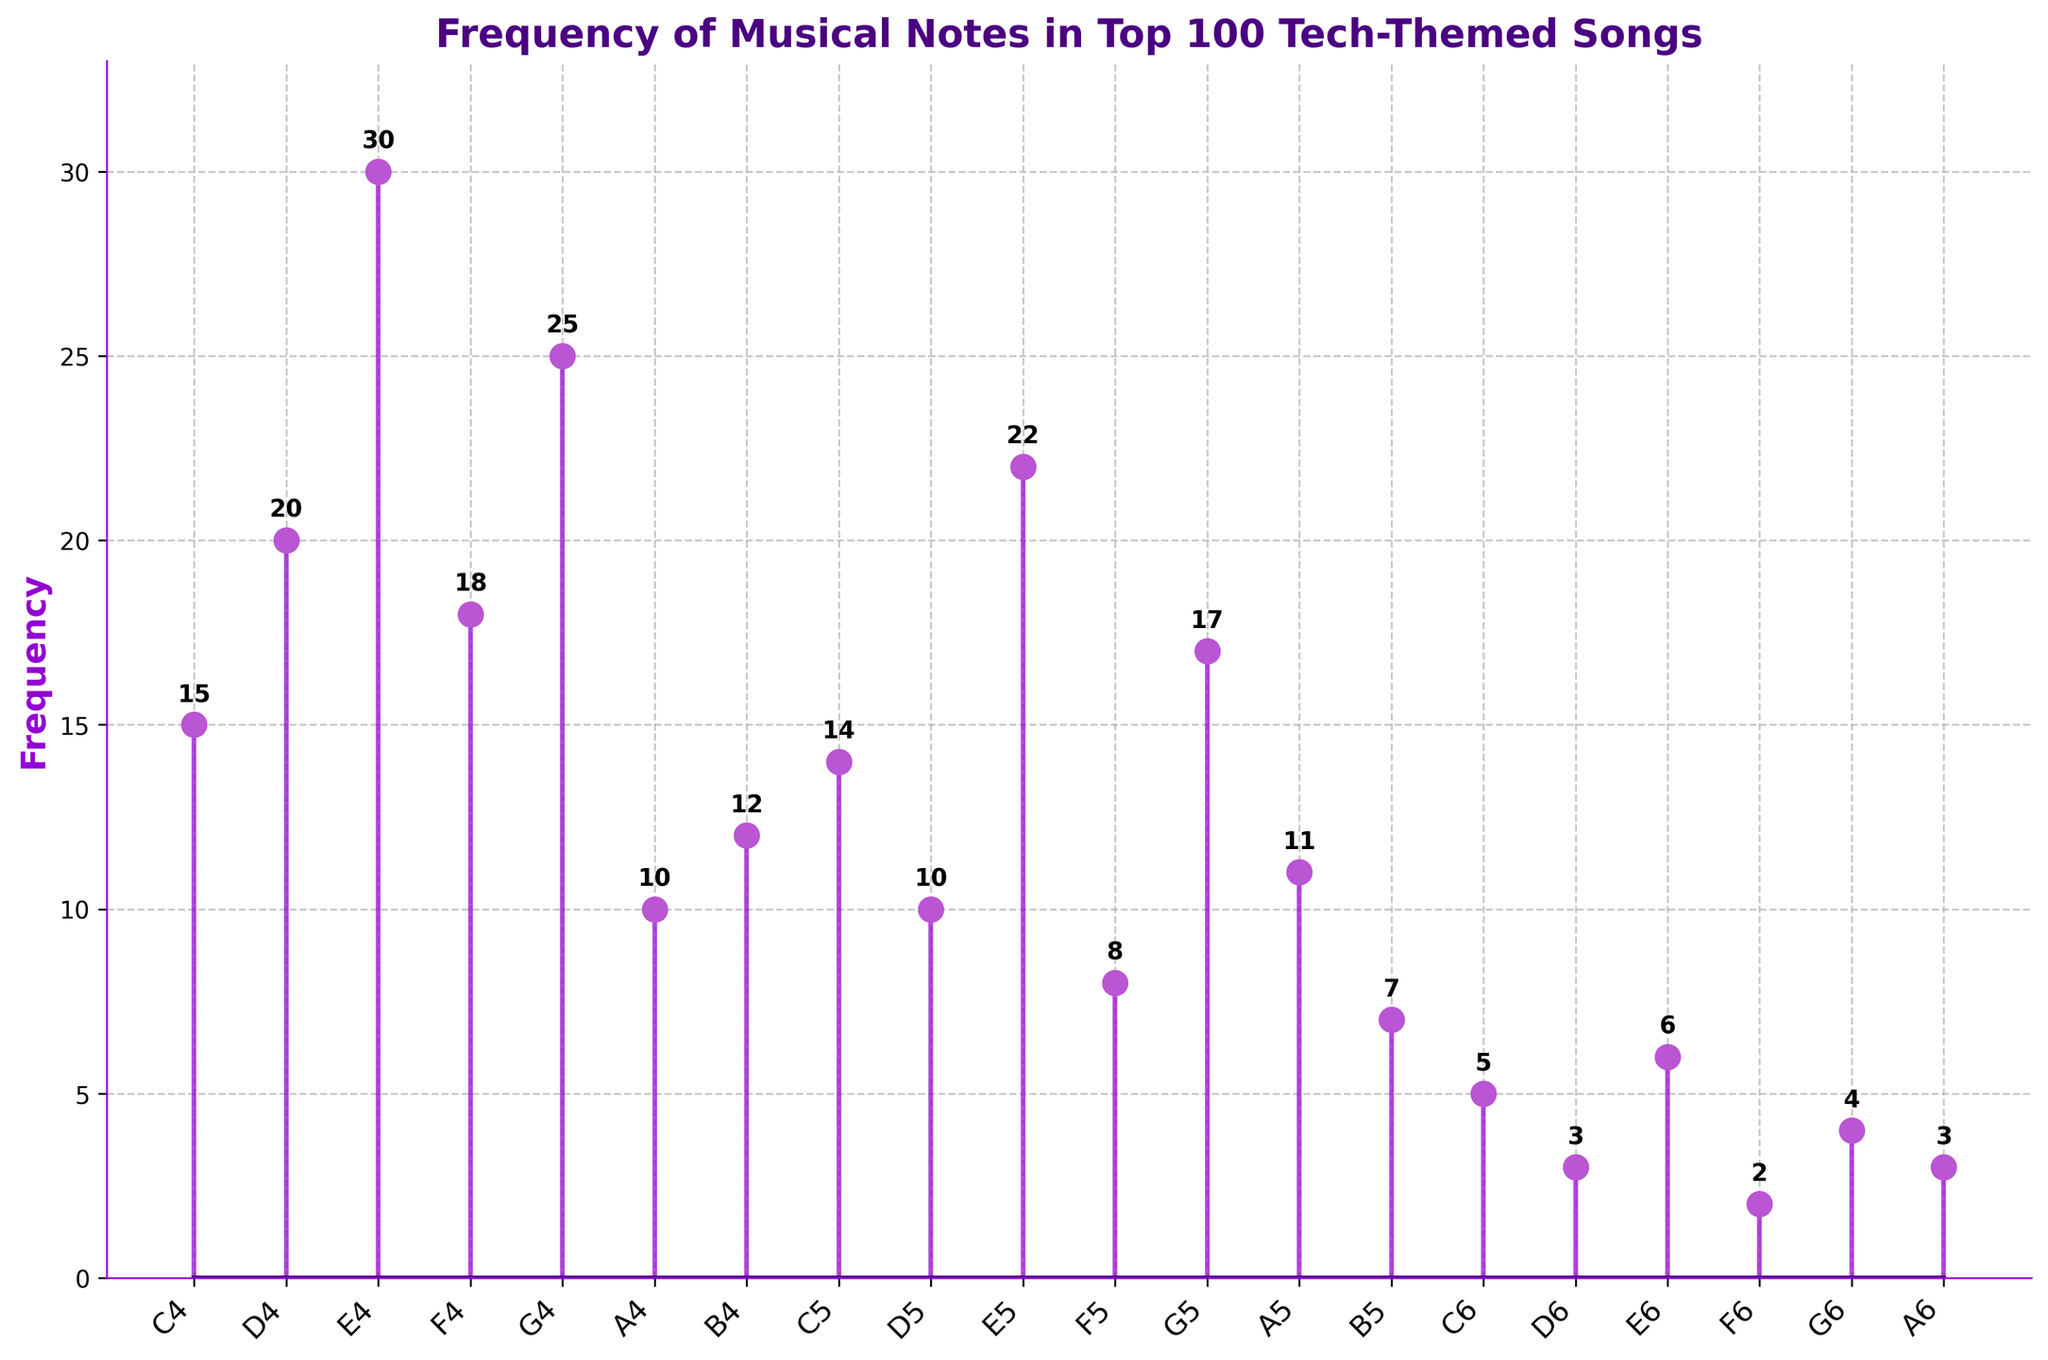What is the title of the figure? The title of the figure is the most prominently placed text at the top, written in large font. Therefore, the title is easily identifiable by looking at the top of the figure.
Answer: Frequency of Musical Notes in Top 100 Tech-Themed Songs How many musical notes are represented in the plot? To find the number of musical notes represented, count the unique labels on the x-axis. These labels are "C4, D4, E4, F4, G4, A4, B4, C5, D5, E5, F5, G5, A5, B5, C6, D6, E6, F6, G6, A6".
Answer: 20 Which musical note has the highest frequency? Examine the heights of the stems in the plot and identify which one reaches the highest point on the y-axis, which is labeled with 'Frequency'. The highest stem corresponds to "E4".
Answer: E4 How many notes have a frequency greater than 20? Look at each stem to determine if the value exceeds 20. The notes "E4 (30)" and "G4 (25)" are the notes with frequencies greater than 20.
Answer: 2 What is the difference in frequency between the most and least frequent notes? The most frequent note is "E4" with a frequency of 30, and the least frequent note is "F6" with a frequency of 2. The difference is calculated as 30 - 2.
Answer: 28 Which musical notes have a frequency of exactly 10? Look for the stems that align with the frequency value of 10 on the y-axis. The notes "A4" and "D5" both match this frequency.
Answer: A4, D5 What is the average frequency of all the notes? Sum all the frequency values: 15 + 20 + 30 + 18 + 25 + 10 + 12 + 14 + 10 + 22 + 8 + 17 + 11 + 7 + 5 + 3 + 6 + 2 + 4 + 3 = 242. Divide by the number of notes: 242 ÷ 20 to get the average frequency.
Answer: 12.1 How does the frequency of "G5" compare to "F4"? Look at the heights of the stems for "G5" and "F4". "G5" has a frequency of 17, while "F4" has a frequency of 18. Therefore, "G5" has a frequency 1 unit less than "F4".
Answer: G5 has a frequency 1 unit less than F4 Which note has a frequency closest to the average frequency of the dataset? The average frequency is 12.1. Looking at the stem plot, "A4" has a frequency of 10 and "E5" has a frequency of 22, and "C4" has 15. "C4" (15) is closer to 12.1 compared to others.
Answer: C4 